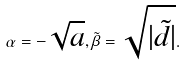<formula> <loc_0><loc_0><loc_500><loc_500>\alpha = - \sqrt { a } , \tilde { \beta } = \sqrt { | \tilde { d } | } .</formula> 